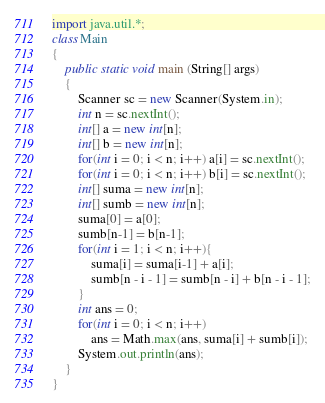Convert code to text. <code><loc_0><loc_0><loc_500><loc_500><_Java_>import java.util.*;
class Main
{
    public static void main (String[] args)
    {
        Scanner sc = new Scanner(System.in);
        int n = sc.nextInt();
        int[] a = new int[n];
        int[] b = new int[n];
        for(int i = 0; i < n; i++) a[i] = sc.nextInt();
        for(int i = 0; i < n; i++) b[i] = sc.nextInt();
        int[] suma = new int[n];
        int[] sumb = new int[n];
        suma[0] = a[0];
        sumb[n-1] = b[n-1];
        for(int i = 1; i < n; i++){
            suma[i] = suma[i-1] + a[i];
            sumb[n - i - 1] = sumb[n - i] + b[n - i - 1];
        }
        int ans = 0;
        for(int i = 0; i < n; i++)
            ans = Math.max(ans, suma[i] + sumb[i]);
        System.out.println(ans);
    }
}</code> 